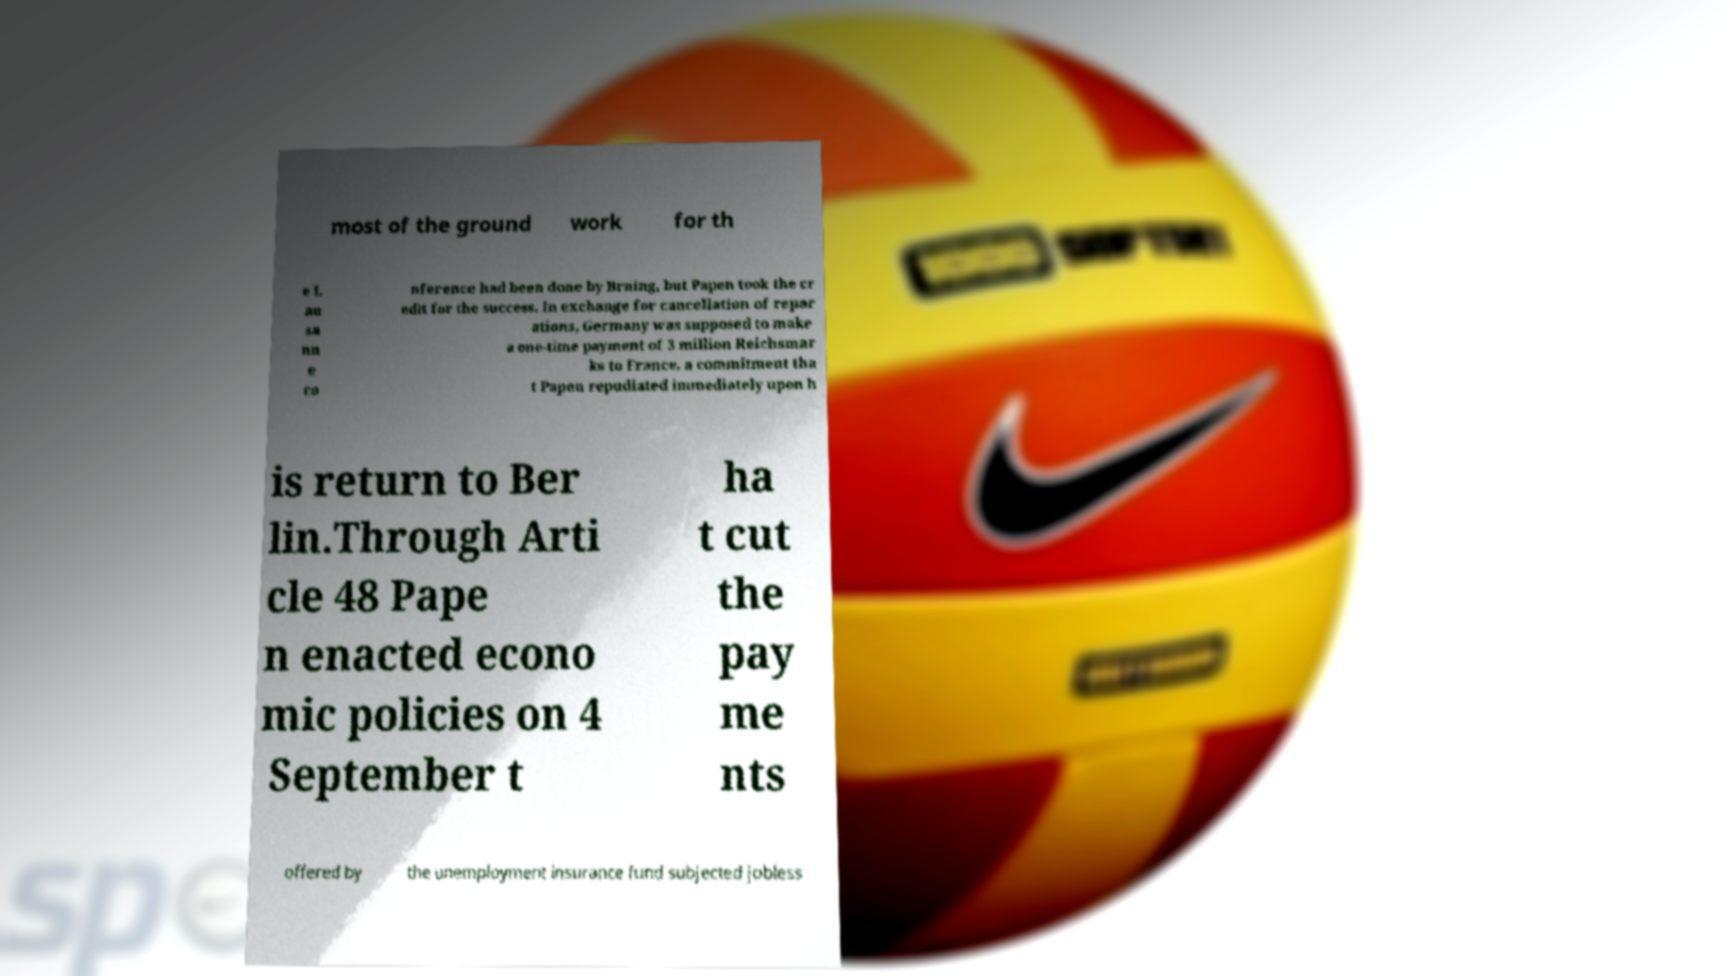There's text embedded in this image that I need extracted. Can you transcribe it verbatim? most of the ground work for th e L au sa nn e co nference had been done by Brning, but Papen took the cr edit for the success. In exchange for cancellation of repar ations, Germany was supposed to make a one-time payment of 3 million Reichsmar ks to France, a commitment tha t Papen repudiated immediately upon h is return to Ber lin.Through Arti cle 48 Pape n enacted econo mic policies on 4 September t ha t cut the pay me nts offered by the unemployment insurance fund subjected jobless 